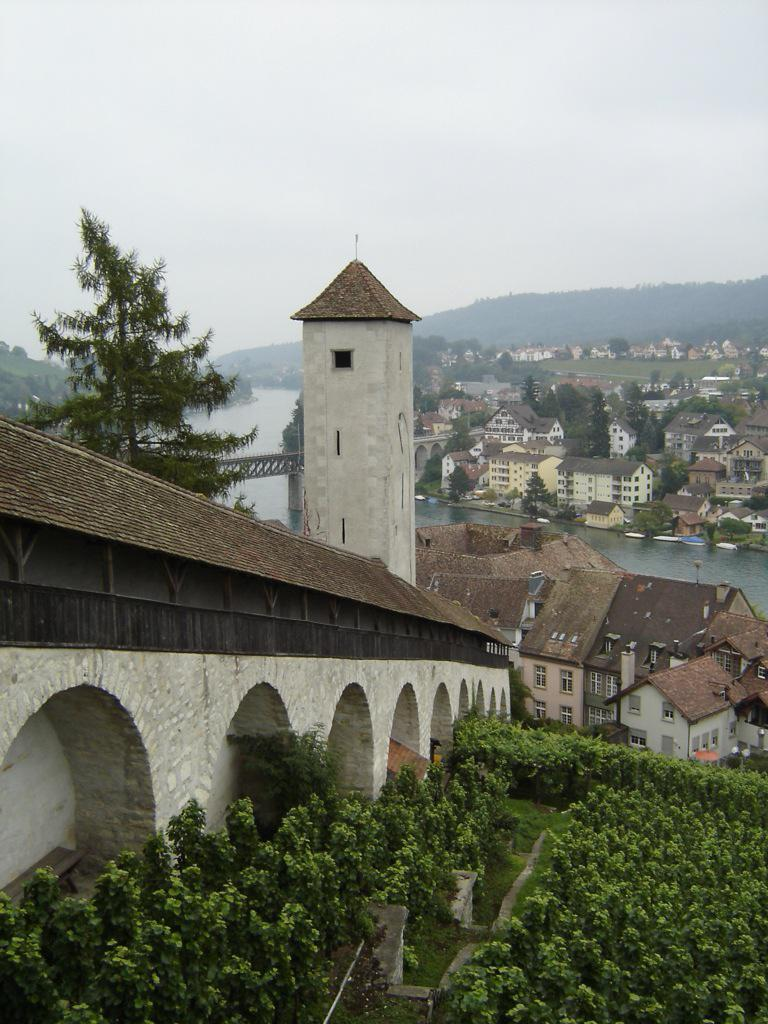What type of vegetation is on the ground in the image? There are plants on the ground in the image. What can be seen in the background of the image? In the background of the image, there is a bridgewater, houses, trees, mountains, and the sky. How many different types of natural features are visible in the background of the image? There are five different types of natural features visible in the background of the image: a bridgewater, houses, trees, mountains, and the sky. What type of pet can be seen in the room in the image? There is no room or pet present in the image. What type of liquid is visible in the image? There is no liquid visible in the image. 